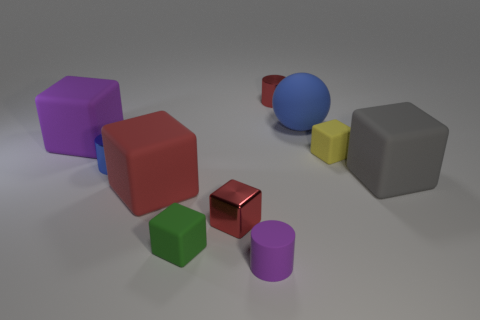Is there a big cyan metallic object that has the same shape as the large red rubber thing?
Provide a short and direct response. No. There is a red matte block that is in front of the red cylinder; is its size the same as the big purple cube?
Your answer should be very brief. Yes. How big is the cylinder that is behind the tiny green matte block and right of the small blue shiny cylinder?
Keep it short and to the point. Small. What number of other things are made of the same material as the small blue cylinder?
Make the answer very short. 2. What is the size of the blue thing that is left of the green rubber cube?
Give a very brief answer. Small. What number of big things are either metallic objects or red rubber balls?
Give a very brief answer. 0. Is there anything else of the same color as the tiny rubber cylinder?
Your answer should be very brief. Yes. There is a small red block; are there any big gray things in front of it?
Provide a short and direct response. No. There is a blue object to the right of the tiny cylinder that is behind the blue matte thing; how big is it?
Your answer should be very brief. Large. Is the number of blue shiny cylinders in front of the small purple thing the same as the number of rubber blocks that are behind the gray thing?
Offer a terse response. No. 